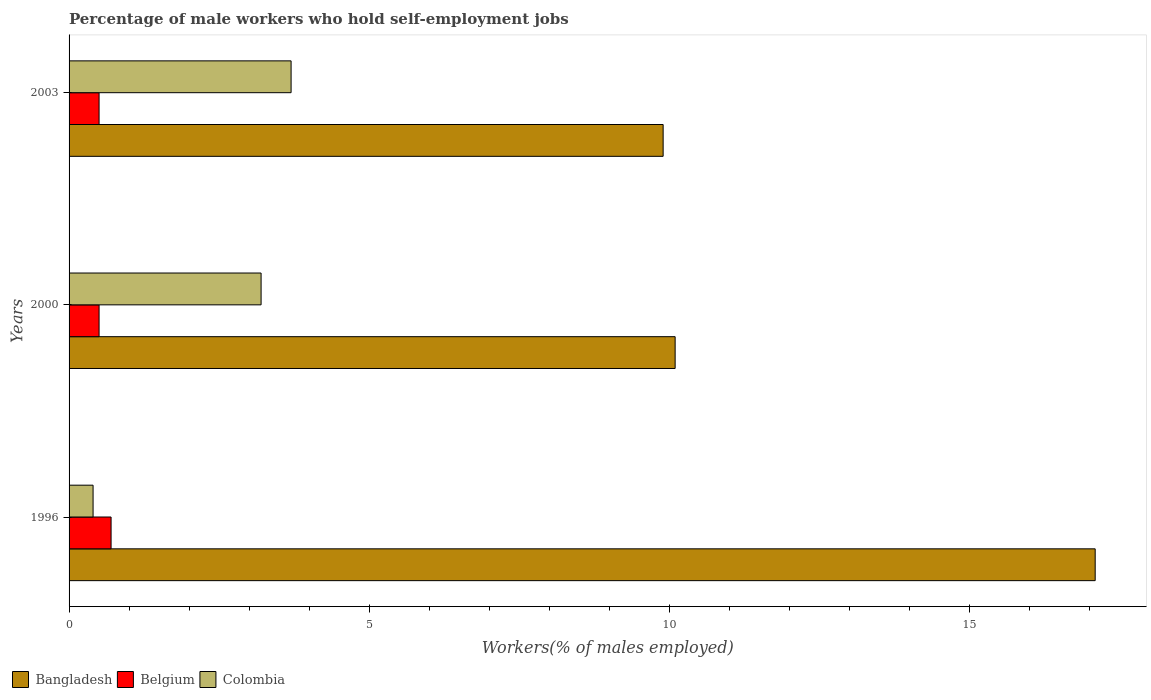How many different coloured bars are there?
Make the answer very short. 3. How many groups of bars are there?
Your answer should be very brief. 3. Are the number of bars on each tick of the Y-axis equal?
Offer a very short reply. Yes. What is the percentage of self-employed male workers in Belgium in 2000?
Offer a terse response. 0.5. Across all years, what is the maximum percentage of self-employed male workers in Belgium?
Keep it short and to the point. 0.7. Across all years, what is the minimum percentage of self-employed male workers in Colombia?
Provide a succinct answer. 0.4. In which year was the percentage of self-employed male workers in Bangladesh minimum?
Provide a succinct answer. 2003. What is the total percentage of self-employed male workers in Colombia in the graph?
Make the answer very short. 7.3. What is the difference between the percentage of self-employed male workers in Belgium in 1996 and that in 2003?
Your answer should be compact. 0.2. What is the difference between the percentage of self-employed male workers in Bangladesh in 1996 and the percentage of self-employed male workers in Belgium in 2000?
Offer a terse response. 16.6. What is the average percentage of self-employed male workers in Colombia per year?
Provide a succinct answer. 2.43. In the year 1996, what is the difference between the percentage of self-employed male workers in Colombia and percentage of self-employed male workers in Bangladesh?
Your answer should be very brief. -16.7. In how many years, is the percentage of self-employed male workers in Bangladesh greater than 5 %?
Provide a short and direct response. 3. What is the ratio of the percentage of self-employed male workers in Colombia in 1996 to that in 2000?
Your response must be concise. 0.12. Is the percentage of self-employed male workers in Bangladesh in 1996 less than that in 2000?
Your answer should be compact. No. What is the difference between the highest and the second highest percentage of self-employed male workers in Bangladesh?
Provide a short and direct response. 7. What is the difference between the highest and the lowest percentage of self-employed male workers in Colombia?
Your response must be concise. 3.3. In how many years, is the percentage of self-employed male workers in Colombia greater than the average percentage of self-employed male workers in Colombia taken over all years?
Your answer should be very brief. 2. Is the sum of the percentage of self-employed male workers in Bangladesh in 2000 and 2003 greater than the maximum percentage of self-employed male workers in Belgium across all years?
Provide a short and direct response. Yes. What does the 3rd bar from the bottom in 1996 represents?
Provide a succinct answer. Colombia. Are the values on the major ticks of X-axis written in scientific E-notation?
Give a very brief answer. No. Does the graph contain any zero values?
Your answer should be very brief. No. Does the graph contain grids?
Provide a succinct answer. No. How many legend labels are there?
Your answer should be very brief. 3. How are the legend labels stacked?
Your answer should be compact. Horizontal. What is the title of the graph?
Your answer should be compact. Percentage of male workers who hold self-employment jobs. What is the label or title of the X-axis?
Provide a succinct answer. Workers(% of males employed). What is the label or title of the Y-axis?
Ensure brevity in your answer.  Years. What is the Workers(% of males employed) in Bangladesh in 1996?
Ensure brevity in your answer.  17.1. What is the Workers(% of males employed) of Belgium in 1996?
Your answer should be very brief. 0.7. What is the Workers(% of males employed) in Colombia in 1996?
Make the answer very short. 0.4. What is the Workers(% of males employed) of Bangladesh in 2000?
Your response must be concise. 10.1. What is the Workers(% of males employed) in Belgium in 2000?
Your answer should be very brief. 0.5. What is the Workers(% of males employed) in Colombia in 2000?
Make the answer very short. 3.2. What is the Workers(% of males employed) of Bangladesh in 2003?
Offer a terse response. 9.9. What is the Workers(% of males employed) of Colombia in 2003?
Your answer should be very brief. 3.7. Across all years, what is the maximum Workers(% of males employed) in Bangladesh?
Make the answer very short. 17.1. Across all years, what is the maximum Workers(% of males employed) in Belgium?
Offer a terse response. 0.7. Across all years, what is the maximum Workers(% of males employed) in Colombia?
Ensure brevity in your answer.  3.7. Across all years, what is the minimum Workers(% of males employed) in Bangladesh?
Keep it short and to the point. 9.9. Across all years, what is the minimum Workers(% of males employed) of Colombia?
Offer a very short reply. 0.4. What is the total Workers(% of males employed) of Bangladesh in the graph?
Offer a terse response. 37.1. What is the difference between the Workers(% of males employed) of Bangladesh in 1996 and that in 2000?
Your answer should be very brief. 7. What is the difference between the Workers(% of males employed) of Bangladesh in 1996 and that in 2003?
Give a very brief answer. 7.2. What is the difference between the Workers(% of males employed) of Belgium in 1996 and that in 2003?
Provide a succinct answer. 0.2. What is the difference between the Workers(% of males employed) of Colombia in 1996 and that in 2003?
Offer a terse response. -3.3. What is the difference between the Workers(% of males employed) in Bangladesh in 1996 and the Workers(% of males employed) in Colombia in 2000?
Offer a terse response. 13.9. What is the difference between the Workers(% of males employed) of Belgium in 1996 and the Workers(% of males employed) of Colombia in 2000?
Your answer should be very brief. -2.5. What is the difference between the Workers(% of males employed) of Bangladesh in 1996 and the Workers(% of males employed) of Colombia in 2003?
Provide a succinct answer. 13.4. What is the difference between the Workers(% of males employed) in Belgium in 1996 and the Workers(% of males employed) in Colombia in 2003?
Provide a succinct answer. -3. What is the difference between the Workers(% of males employed) of Bangladesh in 2000 and the Workers(% of males employed) of Colombia in 2003?
Provide a succinct answer. 6.4. What is the difference between the Workers(% of males employed) in Belgium in 2000 and the Workers(% of males employed) in Colombia in 2003?
Make the answer very short. -3.2. What is the average Workers(% of males employed) of Bangladesh per year?
Provide a short and direct response. 12.37. What is the average Workers(% of males employed) in Belgium per year?
Give a very brief answer. 0.57. What is the average Workers(% of males employed) of Colombia per year?
Your answer should be very brief. 2.43. In the year 1996, what is the difference between the Workers(% of males employed) of Bangladesh and Workers(% of males employed) of Belgium?
Offer a very short reply. 16.4. In the year 1996, what is the difference between the Workers(% of males employed) of Belgium and Workers(% of males employed) of Colombia?
Offer a very short reply. 0.3. In the year 2000, what is the difference between the Workers(% of males employed) in Bangladesh and Workers(% of males employed) in Belgium?
Your response must be concise. 9.6. In the year 2000, what is the difference between the Workers(% of males employed) of Bangladesh and Workers(% of males employed) of Colombia?
Provide a short and direct response. 6.9. What is the ratio of the Workers(% of males employed) in Bangladesh in 1996 to that in 2000?
Provide a short and direct response. 1.69. What is the ratio of the Workers(% of males employed) in Colombia in 1996 to that in 2000?
Your answer should be very brief. 0.12. What is the ratio of the Workers(% of males employed) of Bangladesh in 1996 to that in 2003?
Provide a short and direct response. 1.73. What is the ratio of the Workers(% of males employed) in Colombia in 1996 to that in 2003?
Give a very brief answer. 0.11. What is the ratio of the Workers(% of males employed) in Bangladesh in 2000 to that in 2003?
Offer a terse response. 1.02. What is the ratio of the Workers(% of males employed) in Colombia in 2000 to that in 2003?
Your answer should be compact. 0.86. What is the difference between the highest and the second highest Workers(% of males employed) of Bangladesh?
Your answer should be very brief. 7. What is the difference between the highest and the second highest Workers(% of males employed) of Belgium?
Offer a very short reply. 0.2. What is the difference between the highest and the second highest Workers(% of males employed) of Colombia?
Offer a terse response. 0.5. What is the difference between the highest and the lowest Workers(% of males employed) of Bangladesh?
Offer a terse response. 7.2. What is the difference between the highest and the lowest Workers(% of males employed) in Belgium?
Your response must be concise. 0.2. What is the difference between the highest and the lowest Workers(% of males employed) in Colombia?
Your response must be concise. 3.3. 